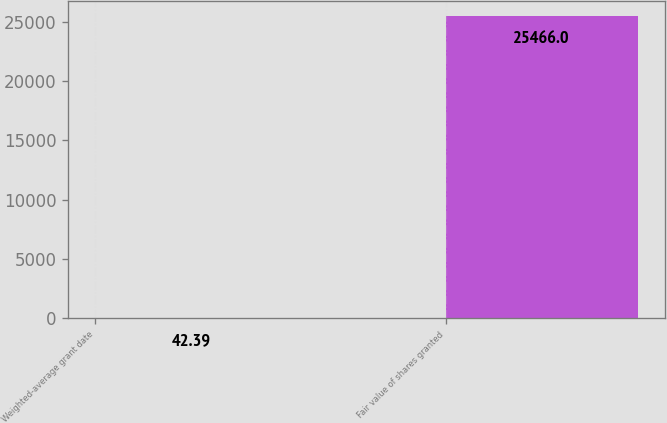Convert chart. <chart><loc_0><loc_0><loc_500><loc_500><bar_chart><fcel>Weighted-average grant date<fcel>Fair value of shares granted<nl><fcel>42.39<fcel>25466<nl></chart> 